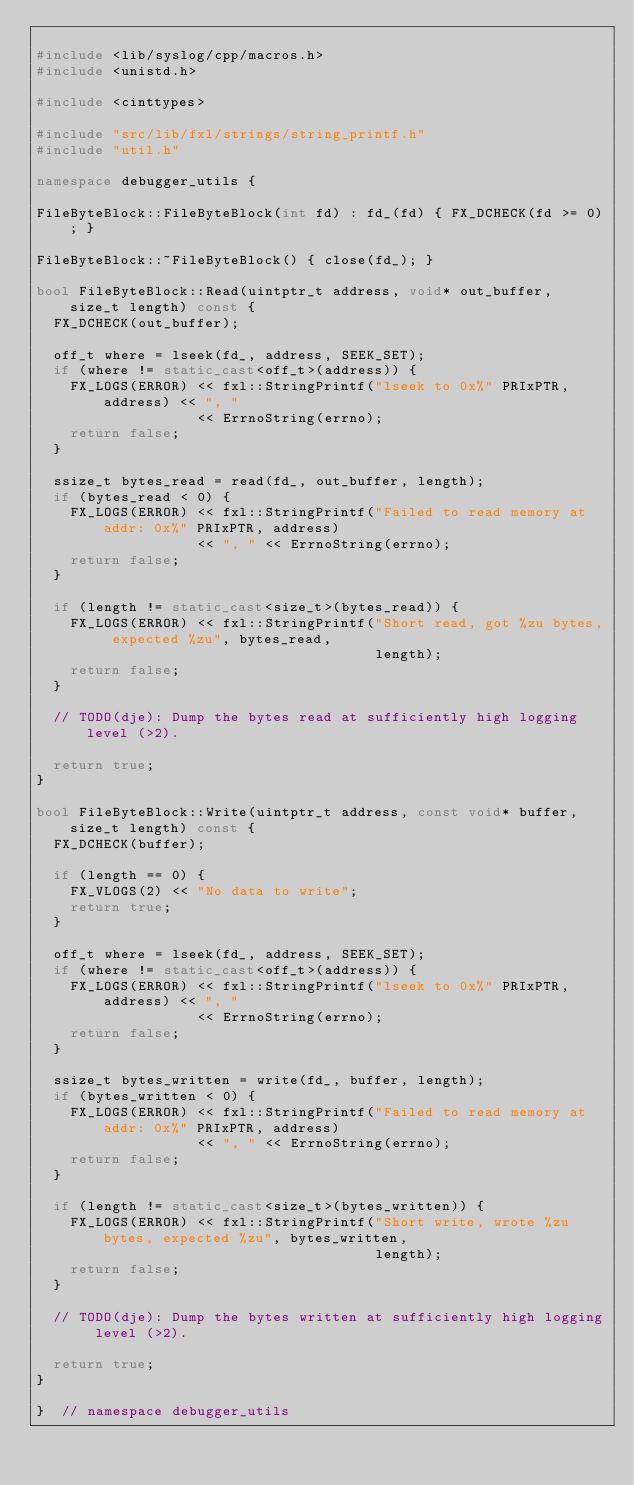Convert code to text. <code><loc_0><loc_0><loc_500><loc_500><_C++_>
#include <lib/syslog/cpp/macros.h>
#include <unistd.h>

#include <cinttypes>

#include "src/lib/fxl/strings/string_printf.h"
#include "util.h"

namespace debugger_utils {

FileByteBlock::FileByteBlock(int fd) : fd_(fd) { FX_DCHECK(fd >= 0); }

FileByteBlock::~FileByteBlock() { close(fd_); }

bool FileByteBlock::Read(uintptr_t address, void* out_buffer, size_t length) const {
  FX_DCHECK(out_buffer);

  off_t where = lseek(fd_, address, SEEK_SET);
  if (where != static_cast<off_t>(address)) {
    FX_LOGS(ERROR) << fxl::StringPrintf("lseek to 0x%" PRIxPTR, address) << ", "
                   << ErrnoString(errno);
    return false;
  }

  ssize_t bytes_read = read(fd_, out_buffer, length);
  if (bytes_read < 0) {
    FX_LOGS(ERROR) << fxl::StringPrintf("Failed to read memory at addr: 0x%" PRIxPTR, address)
                   << ", " << ErrnoString(errno);
    return false;
  }

  if (length != static_cast<size_t>(bytes_read)) {
    FX_LOGS(ERROR) << fxl::StringPrintf("Short read, got %zu bytes, expected %zu", bytes_read,
                                        length);
    return false;
  }

  // TODO(dje): Dump the bytes read at sufficiently high logging level (>2).

  return true;
}

bool FileByteBlock::Write(uintptr_t address, const void* buffer, size_t length) const {
  FX_DCHECK(buffer);

  if (length == 0) {
    FX_VLOGS(2) << "No data to write";
    return true;
  }

  off_t where = lseek(fd_, address, SEEK_SET);
  if (where != static_cast<off_t>(address)) {
    FX_LOGS(ERROR) << fxl::StringPrintf("lseek to 0x%" PRIxPTR, address) << ", "
                   << ErrnoString(errno);
    return false;
  }

  ssize_t bytes_written = write(fd_, buffer, length);
  if (bytes_written < 0) {
    FX_LOGS(ERROR) << fxl::StringPrintf("Failed to read memory at addr: 0x%" PRIxPTR, address)
                   << ", " << ErrnoString(errno);
    return false;
  }

  if (length != static_cast<size_t>(bytes_written)) {
    FX_LOGS(ERROR) << fxl::StringPrintf("Short write, wrote %zu bytes, expected %zu", bytes_written,
                                        length);
    return false;
  }

  // TODO(dje): Dump the bytes written at sufficiently high logging level (>2).

  return true;
}

}  // namespace debugger_utils
</code> 